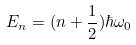<formula> <loc_0><loc_0><loc_500><loc_500>E _ { n } = ( n + \frac { 1 } { 2 } ) \hbar { \omega } _ { 0 }</formula> 